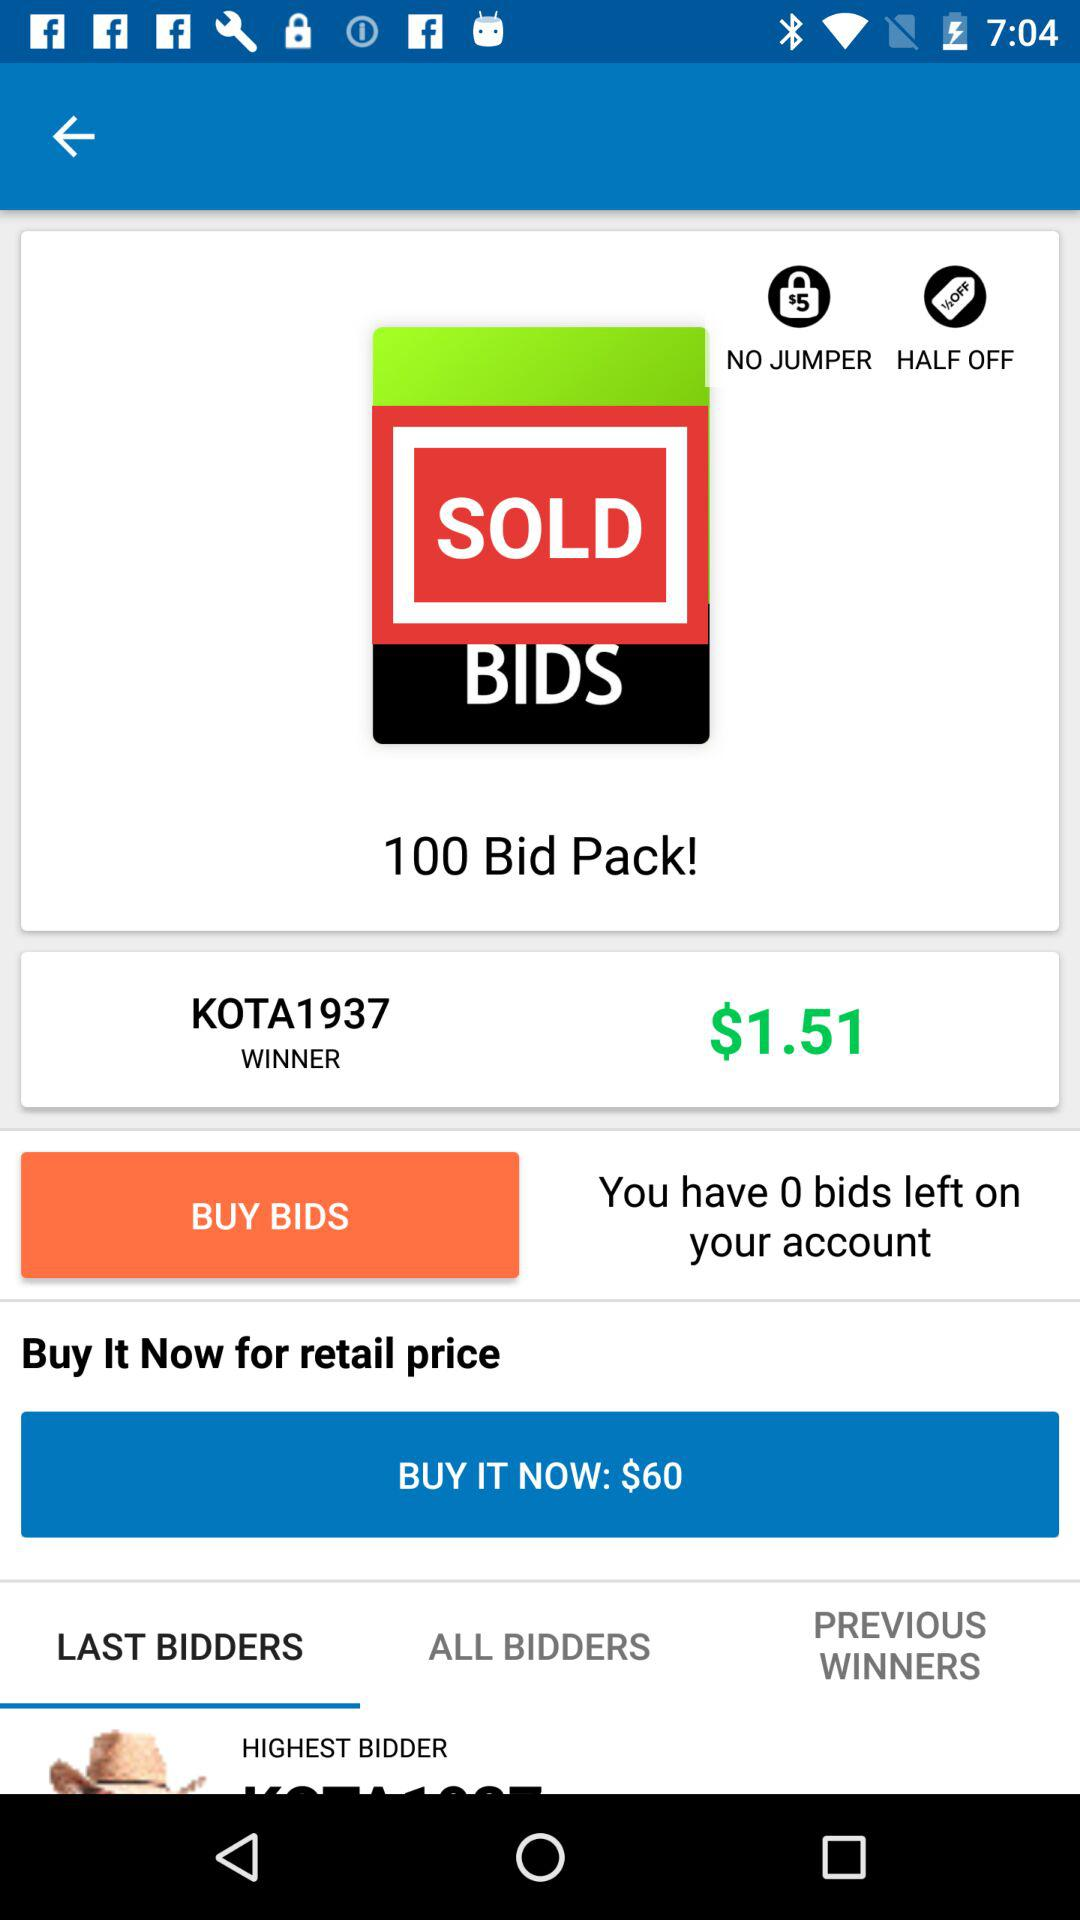What is the highest bid?
Answer the question using a single word or phrase. $1.51 